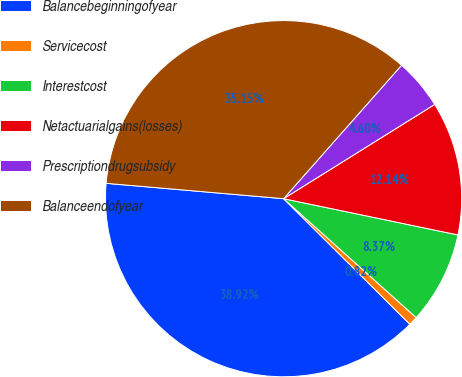Convert chart to OTSL. <chart><loc_0><loc_0><loc_500><loc_500><pie_chart><fcel>Balancebeginningofyear<fcel>Servicecost<fcel>Interestcost<fcel>Netactuarialgains(losses)<fcel>Prescriptiondrugsubsidy<fcel>Balanceendofyear<nl><fcel>38.92%<fcel>0.82%<fcel>8.37%<fcel>12.14%<fcel>4.6%<fcel>35.15%<nl></chart> 